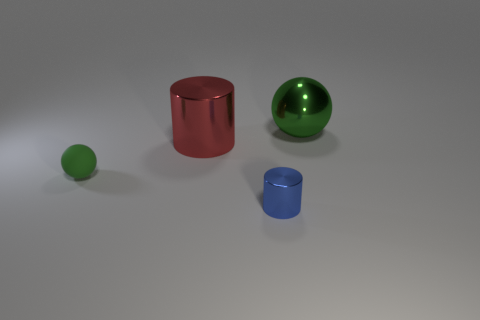What number of small objects have the same color as the big metallic sphere?
Offer a very short reply. 1. How many things are green objects that are to the right of the small green object or blue cylinders?
Offer a terse response. 2. There is a sphere right of the tiny rubber ball; what is its size?
Give a very brief answer. Large. Is the number of big green shiny cylinders less than the number of tiny objects?
Your answer should be compact. Yes. Is the small blue cylinder in front of the tiny green ball made of the same material as the green sphere that is behind the big red metal cylinder?
Give a very brief answer. Yes. There is a metallic object that is in front of the cylinder that is behind the shiny thing in front of the big cylinder; what is its shape?
Offer a terse response. Cylinder. How many yellow objects are the same material as the tiny cylinder?
Provide a short and direct response. 0. There is a large metal thing that is on the left side of the big shiny sphere; how many small green matte spheres are in front of it?
Your answer should be very brief. 1. Do the big shiny object that is right of the blue shiny thing and the large object that is in front of the big green sphere have the same color?
Give a very brief answer. No. What is the shape of the thing that is both in front of the big red cylinder and to the right of the small rubber object?
Ensure brevity in your answer.  Cylinder. 